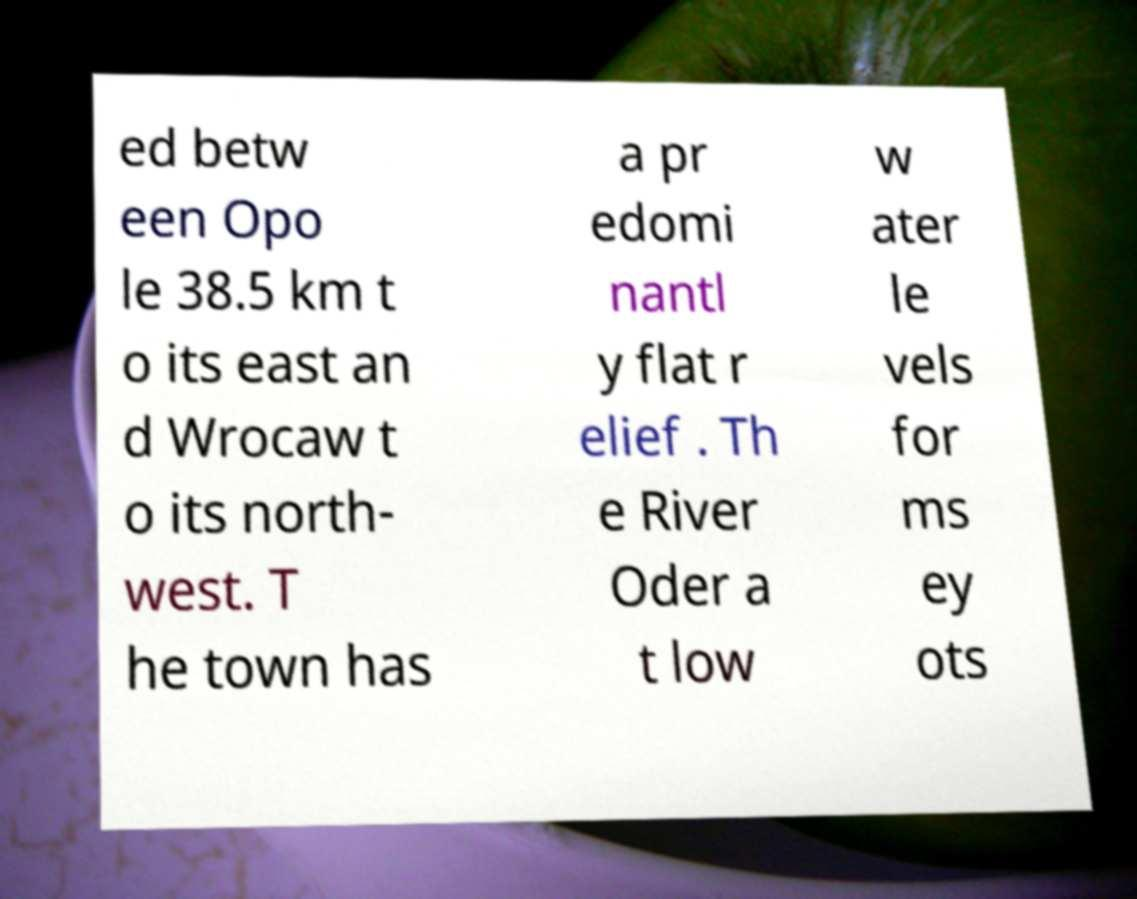Could you extract and type out the text from this image? ed betw een Opo le 38.5 km t o its east an d Wrocaw t o its north- west. T he town has a pr edomi nantl y flat r elief . Th e River Oder a t low w ater le vels for ms ey ots 